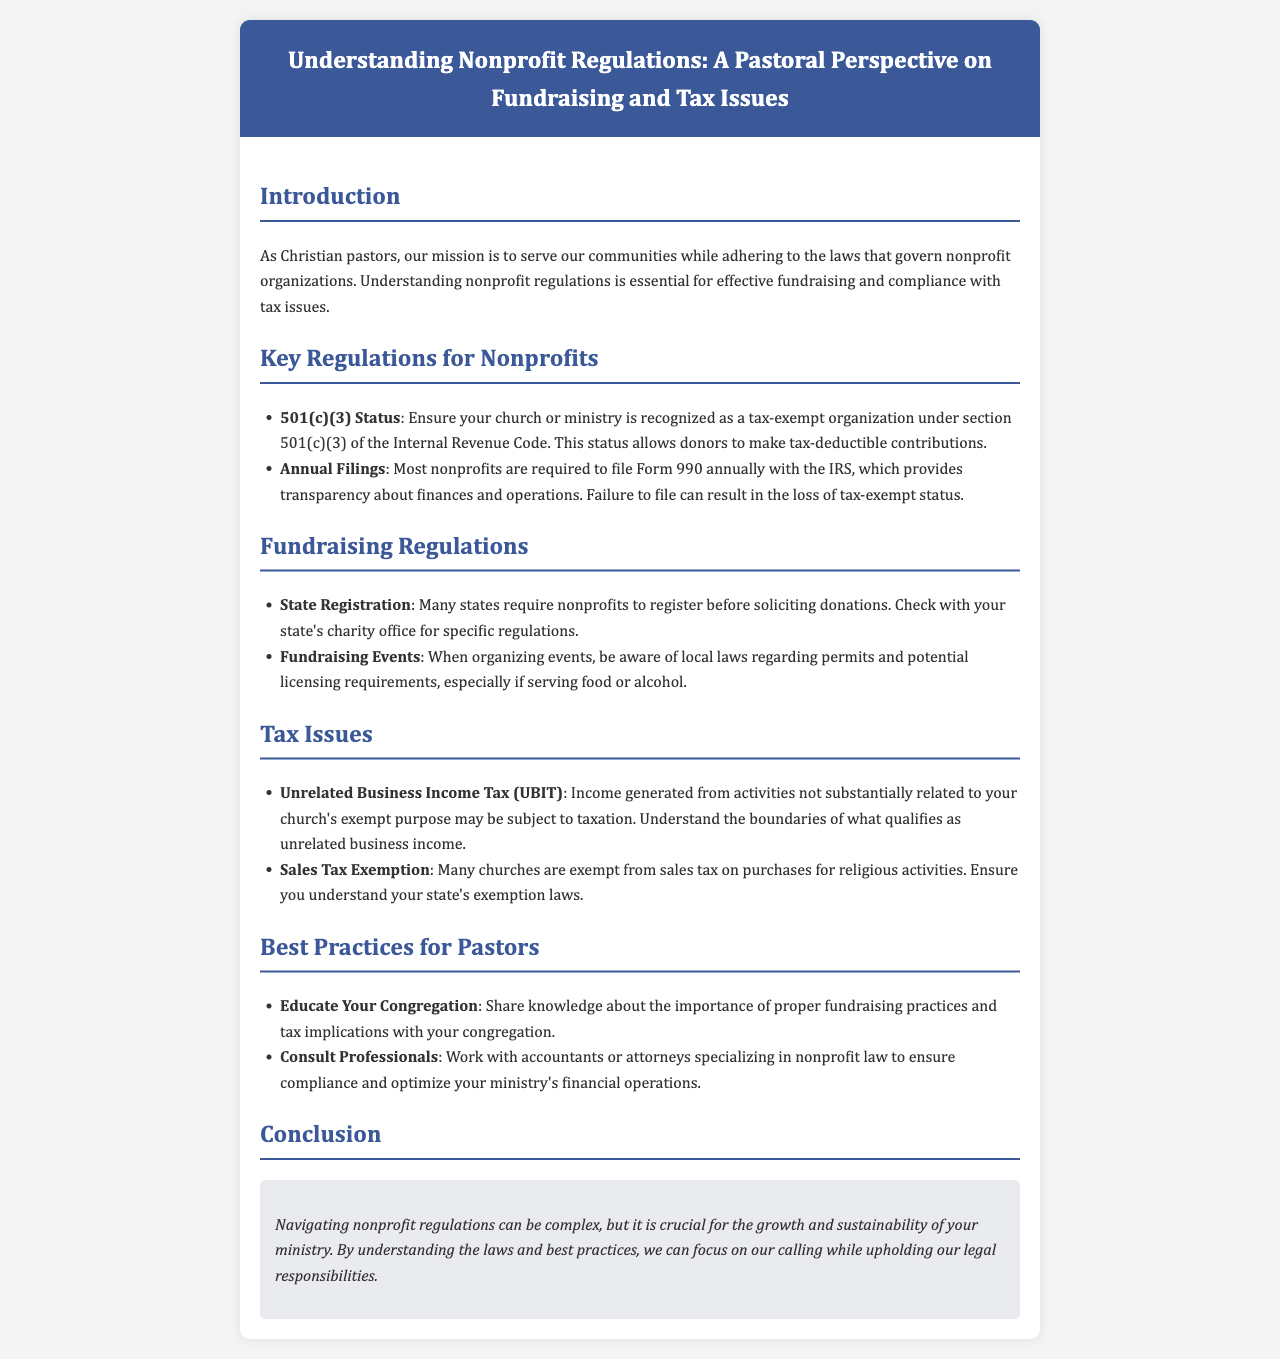what is the title of the brochure? The title is presented in the header section of the document.
Answer: Understanding Nonprofit Regulations: A Pastoral Perspective on Fundraising and Tax Issues what is the section that discusses the tax-exempt status? The section includes important information about tax-exempt status under section 501(c)(3) of the Internal Revenue Code.
Answer: 501(c)(3) Status which form must most nonprofits file annually? The form is required for transparency about finances and operations.
Answer: Form 990 what might happen if a nonprofit fails to file Form 990? This consequence is mentioned in relation to maintaining tax-exempt status.
Answer: Loss of tax-exempt status what does UBIT stand for? This term is mentioned in the context of tax issues related to unrelated income.
Answer: Unrelated Business Income Tax what should pastors do to ensure compliance with nonprofit regulations? This involves seeking help from professionals with specific expertise.
Answer: Consult Professionals which section includes information about fundraising regulations? This section focuses on how to legally solicit donations.
Answer: Fundraising Regulations what is a recommended best practice for pastors regarding fundraising? This practice involves educating their community about proper fundraising methods.
Answer: Educate Your Congregation what is a key takeaway from the conclusion of the brochure? The conclusion summarizes the importance of understanding regulations for ministry growth.
Answer: Legal responsibilities 